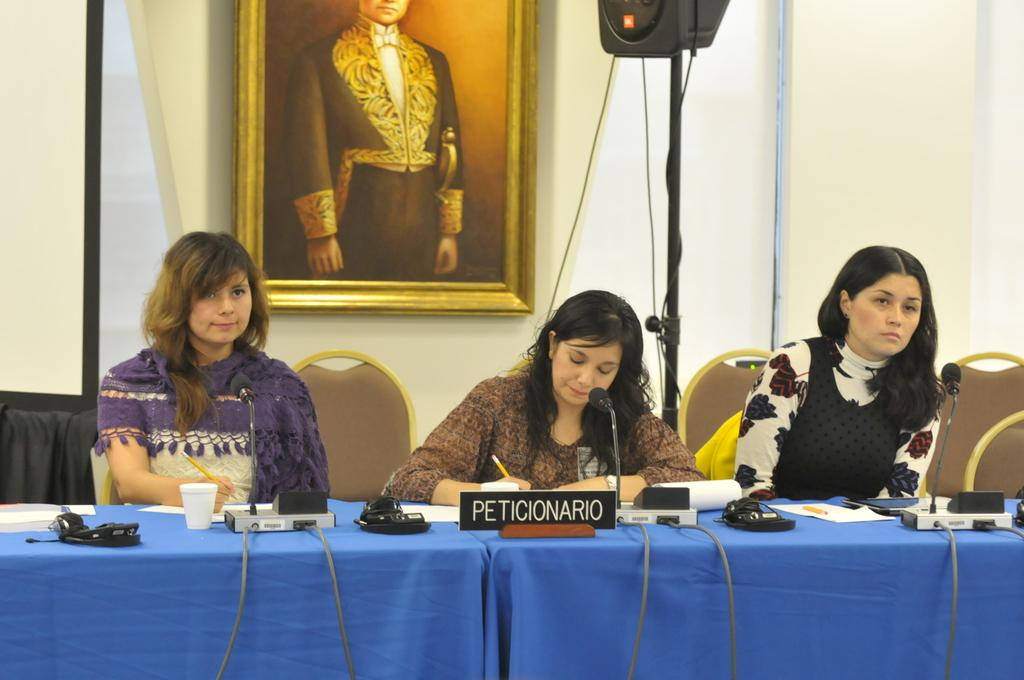Who is present in the image? There are women in the image. What are the women doing in the image? The women are sitting on chairs. What can be seen on the table in the image? There is a glass, a mic with a stand, a paper, and a pencil on the table. How many cows are present in the image? There are no cows present in the image. What type of chain is being used to hold the mic in the image? There is no chain present in the image; the mic is on a stand. 